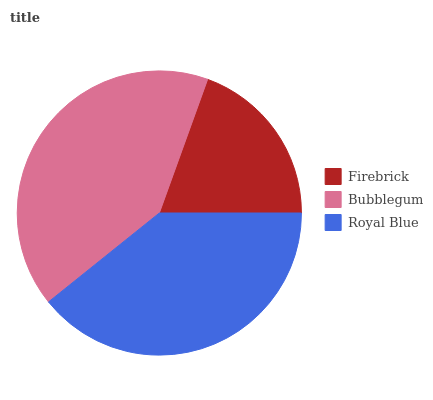Is Firebrick the minimum?
Answer yes or no. Yes. Is Bubblegum the maximum?
Answer yes or no. Yes. Is Royal Blue the minimum?
Answer yes or no. No. Is Royal Blue the maximum?
Answer yes or no. No. Is Bubblegum greater than Royal Blue?
Answer yes or no. Yes. Is Royal Blue less than Bubblegum?
Answer yes or no. Yes. Is Royal Blue greater than Bubblegum?
Answer yes or no. No. Is Bubblegum less than Royal Blue?
Answer yes or no. No. Is Royal Blue the high median?
Answer yes or no. Yes. Is Royal Blue the low median?
Answer yes or no. Yes. Is Bubblegum the high median?
Answer yes or no. No. Is Bubblegum the low median?
Answer yes or no. No. 